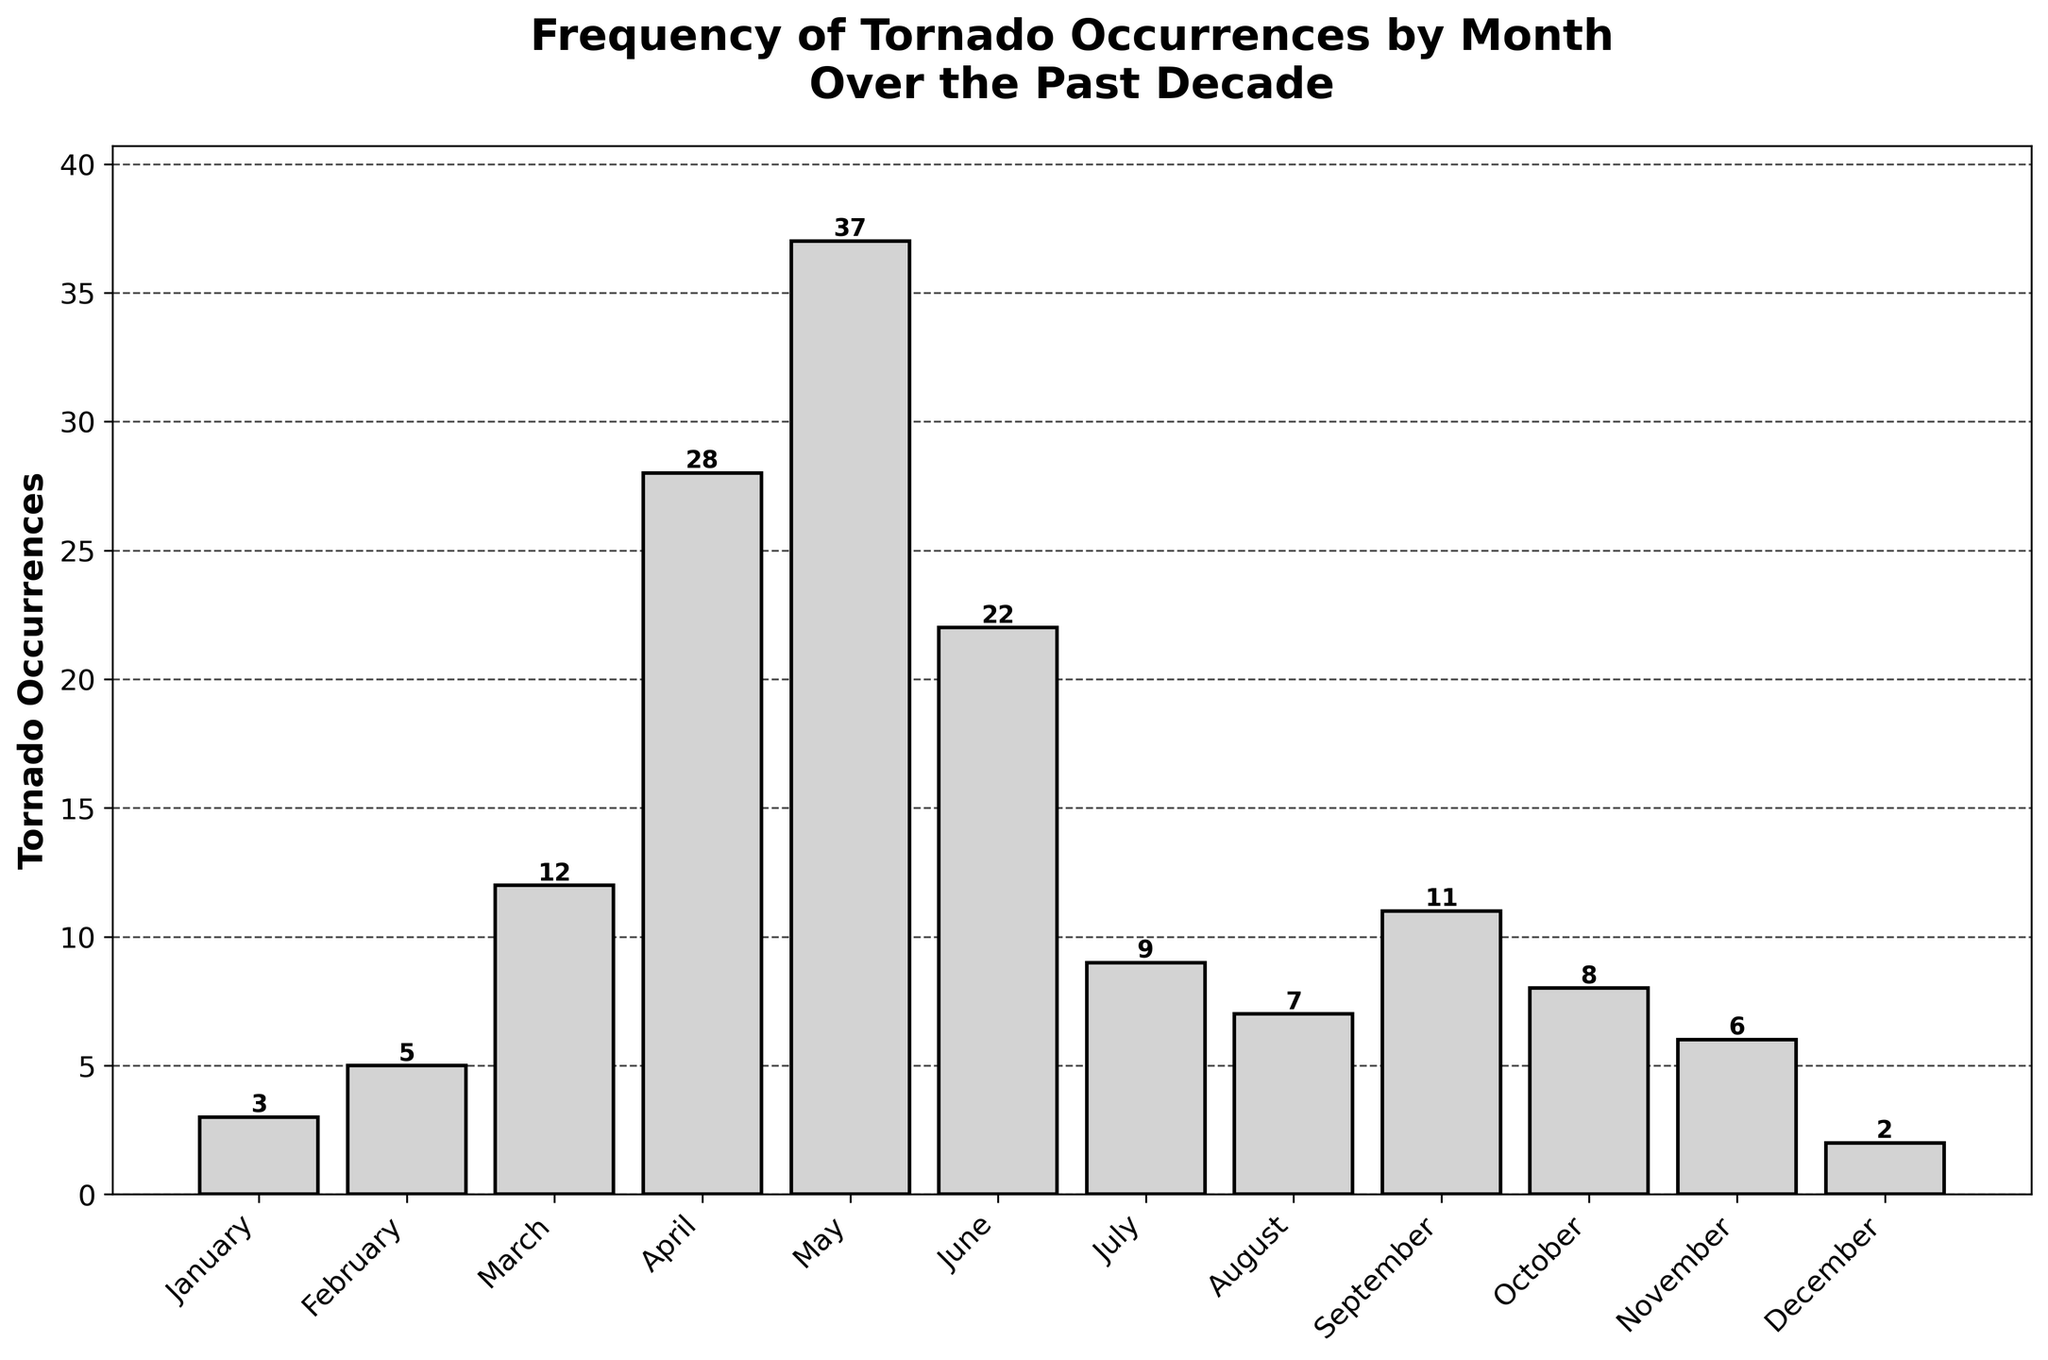Which month has the highest number of tornado occurrences? April has the highest bar in the chart, indicating it has the most number of occurrences compared to other months.
Answer: April What is the difference in tornado occurrences between May and June? From the chart, May has 37 occurrences and June has 22. Subtract 22 from 37 to find the difference.
Answer: 15 During which months are tornado occurrences fewer than 5? By looking at the heights of the bars, January and December have fewer than 5 tornado occurrences each with 3 and 2 respectively.
Answer: January, December What is the sum of tornado occurrences in March, April, and May? From the chart, March has 12, April has 28, and May has 37 occurrences. Add these values: 12 + 28 + 37.
Answer: 77 How does the number of tornado occurrences in July compare to those in August? The bar for July indicates 9 occurrences and the bar for August indicates 7 occurrences. 9 is greater than 7.
Answer: July has more Which month has the lowest number of tornado occurrences? The shortest bar in the chart indicates the month with the lowest occurrences, which is December with 2 occurrences.
Answer: December What is the total number of tornado occurrences from January to June? Add the occurrences of January (3), February (5), March (12), April (28), May (37), and June (22): 3 + 5 + 12 + 28 + 37 + 22.
Answer: 107 Are tornado occurrences more frequent in the first half or the second half of the year? Sum the occurrences for January to June: 3 + 5 + 12 + 28 + 37 + 22 = 107. Sum the occurrences for July to December: 9 + 7 + 11 + 8 + 6 + 2 = 43. Compare the sums: 107 is greater than 43.
Answer: First half What is the average number of tornado occurrences in fall (September, October, November)? Sum the occurrences of September (11), October (8), and November (6), then divide by 3: (11 + 8 + 6) / 3.
Answer: 8.33 